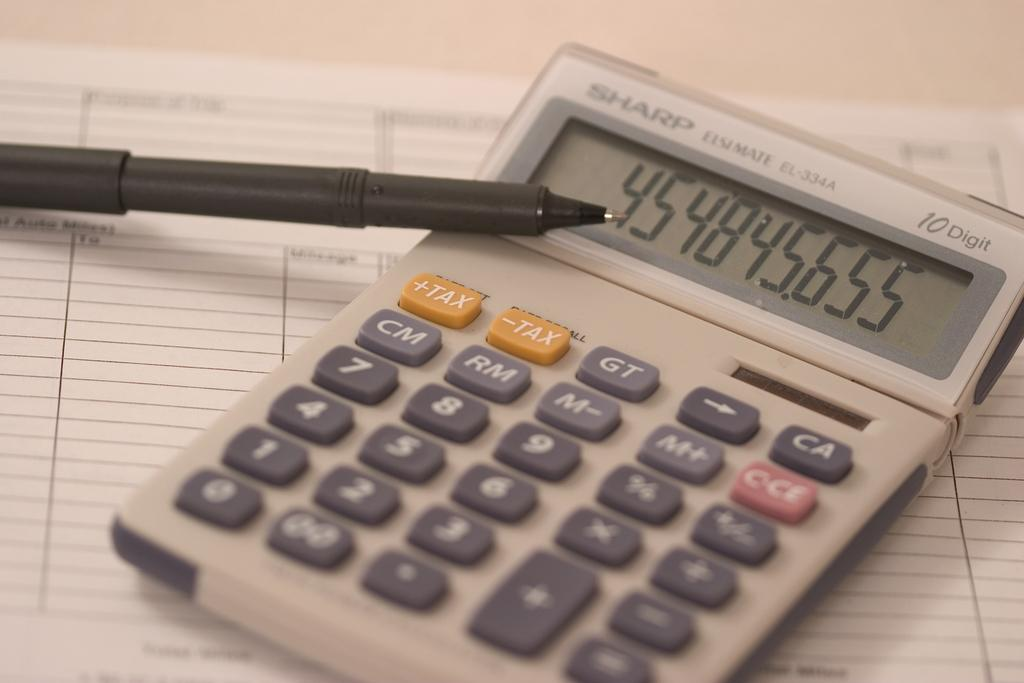<image>
Describe the image concisely. A long string of numbers appear on a Sharp calculator that is sitting on a blank form. 